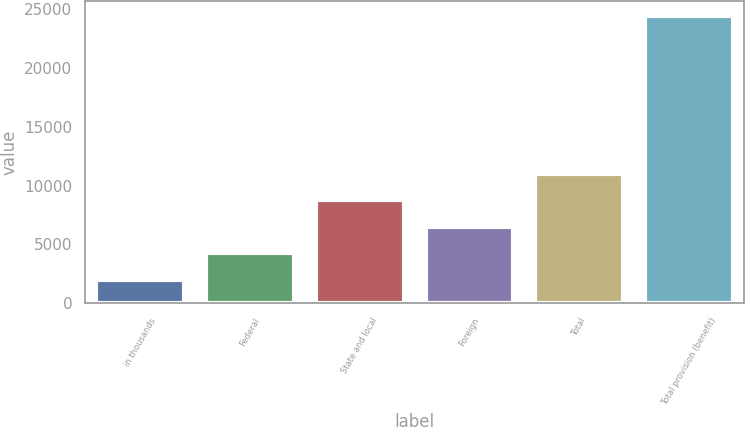<chart> <loc_0><loc_0><loc_500><loc_500><bar_chart><fcel>in thousands<fcel>Federal<fcel>State and local<fcel>Foreign<fcel>Total<fcel>Total provision (benefit)<nl><fcel>2013<fcel>4257.6<fcel>8746.8<fcel>6502.2<fcel>10991.4<fcel>24459<nl></chart> 